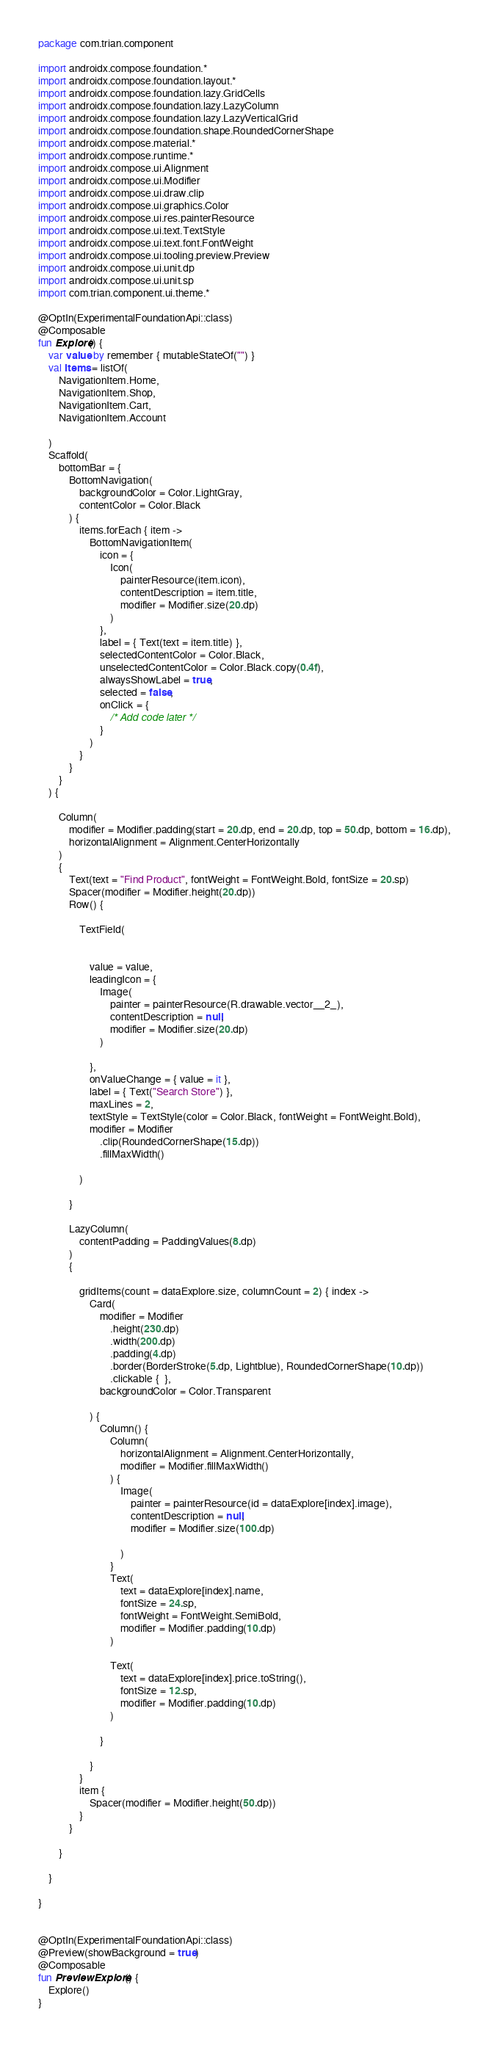<code> <loc_0><loc_0><loc_500><loc_500><_Kotlin_>package com.trian.component

import androidx.compose.foundation.*
import androidx.compose.foundation.layout.*
import androidx.compose.foundation.lazy.GridCells
import androidx.compose.foundation.lazy.LazyColumn
import androidx.compose.foundation.lazy.LazyVerticalGrid
import androidx.compose.foundation.shape.RoundedCornerShape
import androidx.compose.material.*
import androidx.compose.runtime.*
import androidx.compose.ui.Alignment
import androidx.compose.ui.Modifier
import androidx.compose.ui.draw.clip
import androidx.compose.ui.graphics.Color
import androidx.compose.ui.res.painterResource
import androidx.compose.ui.text.TextStyle
import androidx.compose.ui.text.font.FontWeight
import androidx.compose.ui.tooling.preview.Preview
import androidx.compose.ui.unit.dp
import androidx.compose.ui.unit.sp
import com.trian.component.ui.theme.*

@OptIn(ExperimentalFoundationApi::class)
@Composable
fun Explore() {
    var value by remember { mutableStateOf("") }
    val items = listOf(
        NavigationItem.Home,
        NavigationItem.Shop,
        NavigationItem.Cart,
        NavigationItem.Account

    )
    Scaffold(
        bottomBar = {
            BottomNavigation(
                backgroundColor = Color.LightGray,
                contentColor = Color.Black
            ) {
                items.forEach { item ->
                    BottomNavigationItem(
                        icon = {
                            Icon(
                                painterResource(item.icon),
                                contentDescription = item.title,
                                modifier = Modifier.size(20.dp)
                            )
                        },
                        label = { Text(text = item.title) },
                        selectedContentColor = Color.Black,
                        unselectedContentColor = Color.Black.copy(0.4f),
                        alwaysShowLabel = true,
                        selected = false,
                        onClick = {
                            /* Add code later */
                        }
                    )
                }
            }
        }
    ) {

        Column(
            modifier = Modifier.padding(start = 20.dp, end = 20.dp, top = 50.dp, bottom = 16.dp),
            horizontalAlignment = Alignment.CenterHorizontally
        )
        {
            Text(text = "Find Product", fontWeight = FontWeight.Bold, fontSize = 20.sp)
            Spacer(modifier = Modifier.height(20.dp))
            Row() {

                TextField(


                    value = value,
                    leadingIcon = {
                        Image(
                            painter = painterResource(R.drawable.vector__2_),
                            contentDescription = null,
                            modifier = Modifier.size(20.dp)
                        )

                    },
                    onValueChange = { value = it },
                    label = { Text("Search Store") },
                    maxLines = 2,
                    textStyle = TextStyle(color = Color.Black, fontWeight = FontWeight.Bold),
                    modifier = Modifier
                        .clip(RoundedCornerShape(15.dp))
                        .fillMaxWidth()

                )

            }

            LazyColumn(
                contentPadding = PaddingValues(8.dp)
            )
            {

                gridItems(count = dataExplore.size, columnCount = 2) { index ->
                    Card(
                        modifier = Modifier
                            .height(230.dp)
                            .width(200.dp)
                            .padding(4.dp)
                            .border(BorderStroke(5.dp, Lightblue), RoundedCornerShape(10.dp))
                            .clickable {  },
                        backgroundColor = Color.Transparent

                    ) {
                        Column() {
                            Column(
                                horizontalAlignment = Alignment.CenterHorizontally,
                                modifier = Modifier.fillMaxWidth()
                            ) {
                                Image(
                                    painter = painterResource(id = dataExplore[index].image),
                                    contentDescription = null,
                                    modifier = Modifier.size(100.dp)

                                )
                            }
                            Text(
                                text = dataExplore[index].name,
                                fontSize = 24.sp,
                                fontWeight = FontWeight.SemiBold,
                                modifier = Modifier.padding(10.dp)
                            )

                            Text(
                                text = dataExplore[index].price.toString(),
                                fontSize = 12.sp,
                                modifier = Modifier.padding(10.dp)
                            )

                        }

                    }
                }
                item {
                    Spacer(modifier = Modifier.height(50.dp))
                }
            }

        }

    }

}


@OptIn(ExperimentalFoundationApi::class)
@Preview(showBackground = true)
@Composable
fun PreviewExplore() {
    Explore()
}</code> 